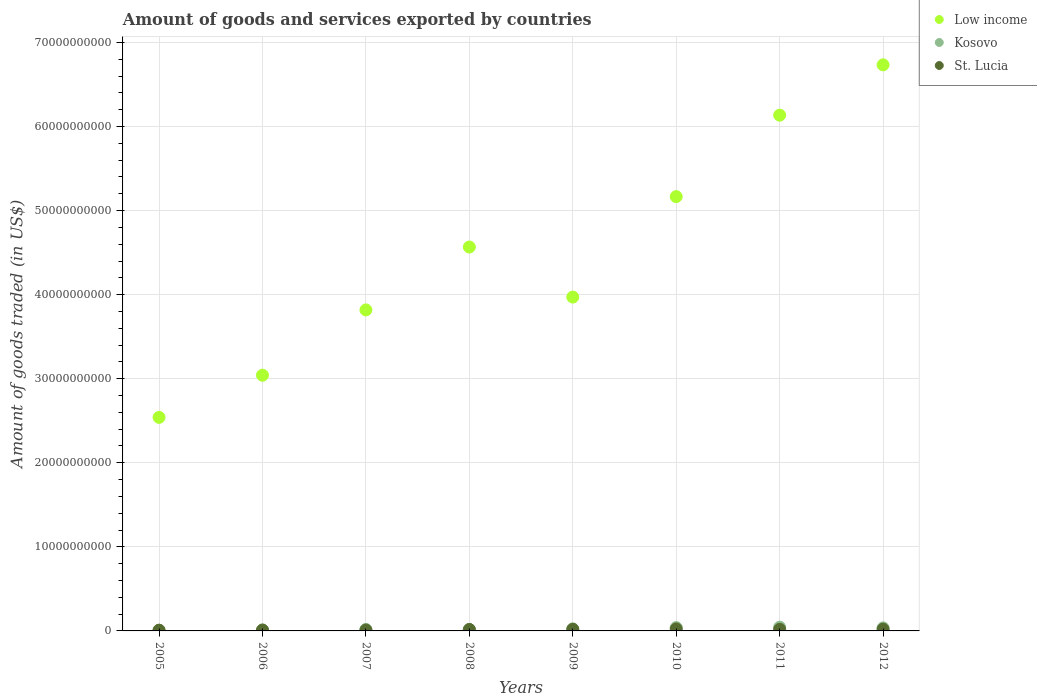What is the total amount of goods and services exported in Low income in 2007?
Offer a very short reply. 3.82e+1. Across all years, what is the maximum total amount of goods and services exported in Kosovo?
Give a very brief answer. 4.41e+08. Across all years, what is the minimum total amount of goods and services exported in Kosovo?
Give a very brief answer. 7.96e+07. In which year was the total amount of goods and services exported in Kosovo maximum?
Your answer should be compact. 2011. What is the total total amount of goods and services exported in Low income in the graph?
Make the answer very short. 3.60e+11. What is the difference between the total amount of goods and services exported in Kosovo in 2007 and that in 2010?
Give a very brief answer. -2.13e+08. What is the difference between the total amount of goods and services exported in Kosovo in 2005 and the total amount of goods and services exported in Low income in 2007?
Your answer should be compact. -3.81e+1. What is the average total amount of goods and services exported in St. Lucia per year?
Keep it short and to the point. 1.62e+08. In the year 2011, what is the difference between the total amount of goods and services exported in Kosovo and total amount of goods and services exported in St. Lucia?
Your answer should be compact. 2.49e+08. In how many years, is the total amount of goods and services exported in St. Lucia greater than 66000000000 US$?
Give a very brief answer. 0. What is the ratio of the total amount of goods and services exported in St. Lucia in 2005 to that in 2007?
Your answer should be very brief. 0.88. Is the total amount of goods and services exported in Kosovo in 2008 less than that in 2009?
Offer a very short reply. Yes. Is the difference between the total amount of goods and services exported in Kosovo in 2007 and 2010 greater than the difference between the total amount of goods and services exported in St. Lucia in 2007 and 2010?
Keep it short and to the point. No. What is the difference between the highest and the second highest total amount of goods and services exported in Kosovo?
Your answer should be very brief. 4.63e+07. What is the difference between the highest and the lowest total amount of goods and services exported in St. Lucia?
Give a very brief answer. 1.50e+08. Is the sum of the total amount of goods and services exported in Low income in 2007 and 2012 greater than the maximum total amount of goods and services exported in Kosovo across all years?
Make the answer very short. Yes. Is it the case that in every year, the sum of the total amount of goods and services exported in Kosovo and total amount of goods and services exported in Low income  is greater than the total amount of goods and services exported in St. Lucia?
Ensure brevity in your answer.  Yes. How many years are there in the graph?
Your answer should be very brief. 8. What is the difference between two consecutive major ticks on the Y-axis?
Ensure brevity in your answer.  1.00e+1. Are the values on the major ticks of Y-axis written in scientific E-notation?
Your answer should be compact. No. Does the graph contain grids?
Ensure brevity in your answer.  Yes. How are the legend labels stacked?
Make the answer very short. Vertical. What is the title of the graph?
Ensure brevity in your answer.  Amount of goods and services exported by countries. Does "Swaziland" appear as one of the legend labels in the graph?
Give a very brief answer. No. What is the label or title of the X-axis?
Your answer should be compact. Years. What is the label or title of the Y-axis?
Make the answer very short. Amount of goods traded (in US$). What is the Amount of goods traded (in US$) of Low income in 2005?
Offer a very short reply. 2.54e+1. What is the Amount of goods traded (in US$) of Kosovo in 2005?
Your answer should be very brief. 7.96e+07. What is the Amount of goods traded (in US$) in St. Lucia in 2005?
Provide a short and direct response. 8.88e+07. What is the Amount of goods traded (in US$) in Low income in 2006?
Ensure brevity in your answer.  3.04e+1. What is the Amount of goods traded (in US$) of Kosovo in 2006?
Offer a terse response. 1.24e+08. What is the Amount of goods traded (in US$) of St. Lucia in 2006?
Offer a very short reply. 9.66e+07. What is the Amount of goods traded (in US$) in Low income in 2007?
Give a very brief answer. 3.82e+1. What is the Amount of goods traded (in US$) in Kosovo in 2007?
Your answer should be very brief. 1.82e+08. What is the Amount of goods traded (in US$) of St. Lucia in 2007?
Keep it short and to the point. 1.01e+08. What is the Amount of goods traded (in US$) in Low income in 2008?
Your answer should be compact. 4.57e+1. What is the Amount of goods traded (in US$) of Kosovo in 2008?
Make the answer very short. 1.76e+08. What is the Amount of goods traded (in US$) in St. Lucia in 2008?
Offer a very short reply. 1.72e+08. What is the Amount of goods traded (in US$) in Low income in 2009?
Ensure brevity in your answer.  3.97e+1. What is the Amount of goods traded (in US$) in Kosovo in 2009?
Provide a succinct answer. 2.43e+08. What is the Amount of goods traded (in US$) of St. Lucia in 2009?
Your response must be concise. 1.91e+08. What is the Amount of goods traded (in US$) in Low income in 2010?
Make the answer very short. 5.17e+1. What is the Amount of goods traded (in US$) in Kosovo in 2010?
Give a very brief answer. 3.95e+08. What is the Amount of goods traded (in US$) of St. Lucia in 2010?
Your answer should be compact. 2.39e+08. What is the Amount of goods traded (in US$) in Low income in 2011?
Ensure brevity in your answer.  6.13e+1. What is the Amount of goods traded (in US$) in Kosovo in 2011?
Offer a terse response. 4.41e+08. What is the Amount of goods traded (in US$) of St. Lucia in 2011?
Give a very brief answer. 1.92e+08. What is the Amount of goods traded (in US$) of Low income in 2012?
Offer a terse response. 6.73e+1. What is the Amount of goods traded (in US$) in Kosovo in 2012?
Ensure brevity in your answer.  3.62e+08. What is the Amount of goods traded (in US$) in St. Lucia in 2012?
Offer a very short reply. 2.12e+08. Across all years, what is the maximum Amount of goods traded (in US$) in Low income?
Your answer should be very brief. 6.73e+1. Across all years, what is the maximum Amount of goods traded (in US$) in Kosovo?
Your answer should be compact. 4.41e+08. Across all years, what is the maximum Amount of goods traded (in US$) of St. Lucia?
Your answer should be very brief. 2.39e+08. Across all years, what is the minimum Amount of goods traded (in US$) of Low income?
Provide a succinct answer. 2.54e+1. Across all years, what is the minimum Amount of goods traded (in US$) of Kosovo?
Your answer should be very brief. 7.96e+07. Across all years, what is the minimum Amount of goods traded (in US$) of St. Lucia?
Your response must be concise. 8.88e+07. What is the total Amount of goods traded (in US$) in Low income in the graph?
Your answer should be compact. 3.60e+11. What is the total Amount of goods traded (in US$) of Kosovo in the graph?
Ensure brevity in your answer.  2.00e+09. What is the total Amount of goods traded (in US$) of St. Lucia in the graph?
Your answer should be compact. 1.29e+09. What is the difference between the Amount of goods traded (in US$) of Low income in 2005 and that in 2006?
Your answer should be very brief. -5.01e+09. What is the difference between the Amount of goods traded (in US$) of Kosovo in 2005 and that in 2006?
Provide a succinct answer. -4.40e+07. What is the difference between the Amount of goods traded (in US$) of St. Lucia in 2005 and that in 2006?
Your answer should be compact. -7.88e+06. What is the difference between the Amount of goods traded (in US$) of Low income in 2005 and that in 2007?
Provide a succinct answer. -1.28e+1. What is the difference between the Amount of goods traded (in US$) in Kosovo in 2005 and that in 2007?
Provide a succinct answer. -1.02e+08. What is the difference between the Amount of goods traded (in US$) in St. Lucia in 2005 and that in 2007?
Make the answer very short. -1.24e+07. What is the difference between the Amount of goods traded (in US$) in Low income in 2005 and that in 2008?
Provide a succinct answer. -2.03e+1. What is the difference between the Amount of goods traded (in US$) of Kosovo in 2005 and that in 2008?
Give a very brief answer. -9.60e+07. What is the difference between the Amount of goods traded (in US$) of St. Lucia in 2005 and that in 2008?
Keep it short and to the point. -8.37e+07. What is the difference between the Amount of goods traded (in US$) of Low income in 2005 and that in 2009?
Your response must be concise. -1.43e+1. What is the difference between the Amount of goods traded (in US$) in Kosovo in 2005 and that in 2009?
Offer a very short reply. -1.63e+08. What is the difference between the Amount of goods traded (in US$) in St. Lucia in 2005 and that in 2009?
Give a very brief answer. -1.03e+08. What is the difference between the Amount of goods traded (in US$) in Low income in 2005 and that in 2010?
Provide a short and direct response. -2.63e+1. What is the difference between the Amount of goods traded (in US$) in Kosovo in 2005 and that in 2010?
Offer a terse response. -3.15e+08. What is the difference between the Amount of goods traded (in US$) in St. Lucia in 2005 and that in 2010?
Make the answer very short. -1.50e+08. What is the difference between the Amount of goods traded (in US$) of Low income in 2005 and that in 2011?
Offer a very short reply. -3.59e+1. What is the difference between the Amount of goods traded (in US$) in Kosovo in 2005 and that in 2011?
Your answer should be compact. -3.62e+08. What is the difference between the Amount of goods traded (in US$) in St. Lucia in 2005 and that in 2011?
Give a very brief answer. -1.04e+08. What is the difference between the Amount of goods traded (in US$) of Low income in 2005 and that in 2012?
Provide a short and direct response. -4.19e+1. What is the difference between the Amount of goods traded (in US$) of Kosovo in 2005 and that in 2012?
Give a very brief answer. -2.82e+08. What is the difference between the Amount of goods traded (in US$) in St. Lucia in 2005 and that in 2012?
Ensure brevity in your answer.  -1.24e+08. What is the difference between the Amount of goods traded (in US$) in Low income in 2006 and that in 2007?
Offer a very short reply. -7.77e+09. What is the difference between the Amount of goods traded (in US$) in Kosovo in 2006 and that in 2007?
Provide a short and direct response. -5.80e+07. What is the difference between the Amount of goods traded (in US$) in St. Lucia in 2006 and that in 2007?
Your response must be concise. -4.57e+06. What is the difference between the Amount of goods traded (in US$) of Low income in 2006 and that in 2008?
Offer a terse response. -1.52e+1. What is the difference between the Amount of goods traded (in US$) in Kosovo in 2006 and that in 2008?
Make the answer very short. -5.21e+07. What is the difference between the Amount of goods traded (in US$) of St. Lucia in 2006 and that in 2008?
Offer a terse response. -7.58e+07. What is the difference between the Amount of goods traded (in US$) in Low income in 2006 and that in 2009?
Ensure brevity in your answer.  -9.30e+09. What is the difference between the Amount of goods traded (in US$) in Kosovo in 2006 and that in 2009?
Offer a very short reply. -1.19e+08. What is the difference between the Amount of goods traded (in US$) in St. Lucia in 2006 and that in 2009?
Offer a very short reply. -9.47e+07. What is the difference between the Amount of goods traded (in US$) in Low income in 2006 and that in 2010?
Provide a short and direct response. -2.12e+1. What is the difference between the Amount of goods traded (in US$) of Kosovo in 2006 and that in 2010?
Your answer should be compact. -2.71e+08. What is the difference between the Amount of goods traded (in US$) of St. Lucia in 2006 and that in 2010?
Your answer should be compact. -1.42e+08. What is the difference between the Amount of goods traded (in US$) of Low income in 2006 and that in 2011?
Keep it short and to the point. -3.09e+1. What is the difference between the Amount of goods traded (in US$) in Kosovo in 2006 and that in 2011?
Provide a succinct answer. -3.18e+08. What is the difference between the Amount of goods traded (in US$) in St. Lucia in 2006 and that in 2011?
Keep it short and to the point. -9.56e+07. What is the difference between the Amount of goods traded (in US$) in Low income in 2006 and that in 2012?
Provide a succinct answer. -3.69e+1. What is the difference between the Amount of goods traded (in US$) of Kosovo in 2006 and that in 2012?
Ensure brevity in your answer.  -2.38e+08. What is the difference between the Amount of goods traded (in US$) in St. Lucia in 2006 and that in 2012?
Make the answer very short. -1.16e+08. What is the difference between the Amount of goods traded (in US$) in Low income in 2007 and that in 2008?
Give a very brief answer. -7.48e+09. What is the difference between the Amount of goods traded (in US$) in Kosovo in 2007 and that in 2008?
Your answer should be very brief. 5.88e+06. What is the difference between the Amount of goods traded (in US$) of St. Lucia in 2007 and that in 2008?
Provide a short and direct response. -7.13e+07. What is the difference between the Amount of goods traded (in US$) of Low income in 2007 and that in 2009?
Make the answer very short. -1.53e+09. What is the difference between the Amount of goods traded (in US$) in Kosovo in 2007 and that in 2009?
Offer a very short reply. -6.15e+07. What is the difference between the Amount of goods traded (in US$) in St. Lucia in 2007 and that in 2009?
Offer a terse response. -9.01e+07. What is the difference between the Amount of goods traded (in US$) of Low income in 2007 and that in 2010?
Your answer should be compact. -1.35e+1. What is the difference between the Amount of goods traded (in US$) in Kosovo in 2007 and that in 2010?
Offer a terse response. -2.13e+08. What is the difference between the Amount of goods traded (in US$) in St. Lucia in 2007 and that in 2010?
Make the answer very short. -1.38e+08. What is the difference between the Amount of goods traded (in US$) of Low income in 2007 and that in 2011?
Make the answer very short. -2.32e+1. What is the difference between the Amount of goods traded (in US$) in Kosovo in 2007 and that in 2011?
Your response must be concise. -2.60e+08. What is the difference between the Amount of goods traded (in US$) of St. Lucia in 2007 and that in 2011?
Provide a succinct answer. -9.11e+07. What is the difference between the Amount of goods traded (in US$) in Low income in 2007 and that in 2012?
Your response must be concise. -2.92e+1. What is the difference between the Amount of goods traded (in US$) of Kosovo in 2007 and that in 2012?
Your answer should be compact. -1.81e+08. What is the difference between the Amount of goods traded (in US$) in St. Lucia in 2007 and that in 2012?
Your answer should be compact. -1.11e+08. What is the difference between the Amount of goods traded (in US$) of Low income in 2008 and that in 2009?
Keep it short and to the point. 5.95e+09. What is the difference between the Amount of goods traded (in US$) of Kosovo in 2008 and that in 2009?
Ensure brevity in your answer.  -6.73e+07. What is the difference between the Amount of goods traded (in US$) in St. Lucia in 2008 and that in 2009?
Provide a succinct answer. -1.88e+07. What is the difference between the Amount of goods traded (in US$) of Low income in 2008 and that in 2010?
Your answer should be very brief. -6.00e+09. What is the difference between the Amount of goods traded (in US$) in Kosovo in 2008 and that in 2010?
Provide a succinct answer. -2.19e+08. What is the difference between the Amount of goods traded (in US$) of St. Lucia in 2008 and that in 2010?
Make the answer very short. -6.64e+07. What is the difference between the Amount of goods traded (in US$) in Low income in 2008 and that in 2011?
Provide a short and direct response. -1.57e+1. What is the difference between the Amount of goods traded (in US$) of Kosovo in 2008 and that in 2011?
Provide a succinct answer. -2.66e+08. What is the difference between the Amount of goods traded (in US$) in St. Lucia in 2008 and that in 2011?
Your answer should be very brief. -1.98e+07. What is the difference between the Amount of goods traded (in US$) in Low income in 2008 and that in 2012?
Give a very brief answer. -2.17e+1. What is the difference between the Amount of goods traded (in US$) in Kosovo in 2008 and that in 2012?
Your answer should be compact. -1.86e+08. What is the difference between the Amount of goods traded (in US$) of St. Lucia in 2008 and that in 2012?
Make the answer very short. -4.00e+07. What is the difference between the Amount of goods traded (in US$) of Low income in 2009 and that in 2010?
Offer a very short reply. -1.19e+1. What is the difference between the Amount of goods traded (in US$) of Kosovo in 2009 and that in 2010?
Your answer should be compact. -1.52e+08. What is the difference between the Amount of goods traded (in US$) in St. Lucia in 2009 and that in 2010?
Make the answer very short. -4.76e+07. What is the difference between the Amount of goods traded (in US$) in Low income in 2009 and that in 2011?
Provide a short and direct response. -2.16e+1. What is the difference between the Amount of goods traded (in US$) in Kosovo in 2009 and that in 2011?
Your answer should be compact. -1.98e+08. What is the difference between the Amount of goods traded (in US$) of St. Lucia in 2009 and that in 2011?
Keep it short and to the point. -9.51e+05. What is the difference between the Amount of goods traded (in US$) in Low income in 2009 and that in 2012?
Keep it short and to the point. -2.76e+1. What is the difference between the Amount of goods traded (in US$) in Kosovo in 2009 and that in 2012?
Provide a succinct answer. -1.19e+08. What is the difference between the Amount of goods traded (in US$) of St. Lucia in 2009 and that in 2012?
Offer a terse response. -2.11e+07. What is the difference between the Amount of goods traded (in US$) in Low income in 2010 and that in 2011?
Give a very brief answer. -9.69e+09. What is the difference between the Amount of goods traded (in US$) in Kosovo in 2010 and that in 2011?
Provide a short and direct response. -4.63e+07. What is the difference between the Amount of goods traded (in US$) of St. Lucia in 2010 and that in 2011?
Offer a terse response. 4.66e+07. What is the difference between the Amount of goods traded (in US$) in Low income in 2010 and that in 2012?
Make the answer very short. -1.57e+1. What is the difference between the Amount of goods traded (in US$) in Kosovo in 2010 and that in 2012?
Keep it short and to the point. 3.28e+07. What is the difference between the Amount of goods traded (in US$) in St. Lucia in 2010 and that in 2012?
Give a very brief answer. 2.65e+07. What is the difference between the Amount of goods traded (in US$) of Low income in 2011 and that in 2012?
Offer a very short reply. -5.99e+09. What is the difference between the Amount of goods traded (in US$) in Kosovo in 2011 and that in 2012?
Provide a short and direct response. 7.92e+07. What is the difference between the Amount of goods traded (in US$) in St. Lucia in 2011 and that in 2012?
Provide a short and direct response. -2.02e+07. What is the difference between the Amount of goods traded (in US$) in Low income in 2005 and the Amount of goods traded (in US$) in Kosovo in 2006?
Provide a short and direct response. 2.53e+1. What is the difference between the Amount of goods traded (in US$) in Low income in 2005 and the Amount of goods traded (in US$) in St. Lucia in 2006?
Provide a short and direct response. 2.53e+1. What is the difference between the Amount of goods traded (in US$) of Kosovo in 2005 and the Amount of goods traded (in US$) of St. Lucia in 2006?
Offer a very short reply. -1.70e+07. What is the difference between the Amount of goods traded (in US$) in Low income in 2005 and the Amount of goods traded (in US$) in Kosovo in 2007?
Keep it short and to the point. 2.52e+1. What is the difference between the Amount of goods traded (in US$) of Low income in 2005 and the Amount of goods traded (in US$) of St. Lucia in 2007?
Keep it short and to the point. 2.53e+1. What is the difference between the Amount of goods traded (in US$) in Kosovo in 2005 and the Amount of goods traded (in US$) in St. Lucia in 2007?
Offer a very short reply. -2.16e+07. What is the difference between the Amount of goods traded (in US$) in Low income in 2005 and the Amount of goods traded (in US$) in Kosovo in 2008?
Your answer should be very brief. 2.52e+1. What is the difference between the Amount of goods traded (in US$) in Low income in 2005 and the Amount of goods traded (in US$) in St. Lucia in 2008?
Your answer should be very brief. 2.52e+1. What is the difference between the Amount of goods traded (in US$) of Kosovo in 2005 and the Amount of goods traded (in US$) of St. Lucia in 2008?
Offer a very short reply. -9.28e+07. What is the difference between the Amount of goods traded (in US$) of Low income in 2005 and the Amount of goods traded (in US$) of Kosovo in 2009?
Provide a succinct answer. 2.52e+1. What is the difference between the Amount of goods traded (in US$) in Low income in 2005 and the Amount of goods traded (in US$) in St. Lucia in 2009?
Ensure brevity in your answer.  2.52e+1. What is the difference between the Amount of goods traded (in US$) in Kosovo in 2005 and the Amount of goods traded (in US$) in St. Lucia in 2009?
Provide a short and direct response. -1.12e+08. What is the difference between the Amount of goods traded (in US$) in Low income in 2005 and the Amount of goods traded (in US$) in Kosovo in 2010?
Your response must be concise. 2.50e+1. What is the difference between the Amount of goods traded (in US$) in Low income in 2005 and the Amount of goods traded (in US$) in St. Lucia in 2010?
Your answer should be very brief. 2.52e+1. What is the difference between the Amount of goods traded (in US$) of Kosovo in 2005 and the Amount of goods traded (in US$) of St. Lucia in 2010?
Ensure brevity in your answer.  -1.59e+08. What is the difference between the Amount of goods traded (in US$) of Low income in 2005 and the Amount of goods traded (in US$) of Kosovo in 2011?
Ensure brevity in your answer.  2.50e+1. What is the difference between the Amount of goods traded (in US$) in Low income in 2005 and the Amount of goods traded (in US$) in St. Lucia in 2011?
Provide a succinct answer. 2.52e+1. What is the difference between the Amount of goods traded (in US$) in Kosovo in 2005 and the Amount of goods traded (in US$) in St. Lucia in 2011?
Keep it short and to the point. -1.13e+08. What is the difference between the Amount of goods traded (in US$) in Low income in 2005 and the Amount of goods traded (in US$) in Kosovo in 2012?
Provide a succinct answer. 2.50e+1. What is the difference between the Amount of goods traded (in US$) in Low income in 2005 and the Amount of goods traded (in US$) in St. Lucia in 2012?
Ensure brevity in your answer.  2.52e+1. What is the difference between the Amount of goods traded (in US$) in Kosovo in 2005 and the Amount of goods traded (in US$) in St. Lucia in 2012?
Offer a terse response. -1.33e+08. What is the difference between the Amount of goods traded (in US$) in Low income in 2006 and the Amount of goods traded (in US$) in Kosovo in 2007?
Make the answer very short. 3.02e+1. What is the difference between the Amount of goods traded (in US$) of Low income in 2006 and the Amount of goods traded (in US$) of St. Lucia in 2007?
Provide a short and direct response. 3.03e+1. What is the difference between the Amount of goods traded (in US$) in Kosovo in 2006 and the Amount of goods traded (in US$) in St. Lucia in 2007?
Provide a short and direct response. 2.24e+07. What is the difference between the Amount of goods traded (in US$) of Low income in 2006 and the Amount of goods traded (in US$) of Kosovo in 2008?
Provide a short and direct response. 3.02e+1. What is the difference between the Amount of goods traded (in US$) of Low income in 2006 and the Amount of goods traded (in US$) of St. Lucia in 2008?
Keep it short and to the point. 3.02e+1. What is the difference between the Amount of goods traded (in US$) of Kosovo in 2006 and the Amount of goods traded (in US$) of St. Lucia in 2008?
Give a very brief answer. -4.89e+07. What is the difference between the Amount of goods traded (in US$) in Low income in 2006 and the Amount of goods traded (in US$) in Kosovo in 2009?
Your answer should be compact. 3.02e+1. What is the difference between the Amount of goods traded (in US$) of Low income in 2006 and the Amount of goods traded (in US$) of St. Lucia in 2009?
Your answer should be compact. 3.02e+1. What is the difference between the Amount of goods traded (in US$) of Kosovo in 2006 and the Amount of goods traded (in US$) of St. Lucia in 2009?
Your answer should be compact. -6.77e+07. What is the difference between the Amount of goods traded (in US$) of Low income in 2006 and the Amount of goods traded (in US$) of Kosovo in 2010?
Your answer should be compact. 3.00e+1. What is the difference between the Amount of goods traded (in US$) in Low income in 2006 and the Amount of goods traded (in US$) in St. Lucia in 2010?
Make the answer very short. 3.02e+1. What is the difference between the Amount of goods traded (in US$) in Kosovo in 2006 and the Amount of goods traded (in US$) in St. Lucia in 2010?
Offer a very short reply. -1.15e+08. What is the difference between the Amount of goods traded (in US$) in Low income in 2006 and the Amount of goods traded (in US$) in Kosovo in 2011?
Make the answer very short. 3.00e+1. What is the difference between the Amount of goods traded (in US$) of Low income in 2006 and the Amount of goods traded (in US$) of St. Lucia in 2011?
Ensure brevity in your answer.  3.02e+1. What is the difference between the Amount of goods traded (in US$) of Kosovo in 2006 and the Amount of goods traded (in US$) of St. Lucia in 2011?
Offer a very short reply. -6.87e+07. What is the difference between the Amount of goods traded (in US$) in Low income in 2006 and the Amount of goods traded (in US$) in Kosovo in 2012?
Make the answer very short. 3.01e+1. What is the difference between the Amount of goods traded (in US$) of Low income in 2006 and the Amount of goods traded (in US$) of St. Lucia in 2012?
Make the answer very short. 3.02e+1. What is the difference between the Amount of goods traded (in US$) in Kosovo in 2006 and the Amount of goods traded (in US$) in St. Lucia in 2012?
Your answer should be compact. -8.88e+07. What is the difference between the Amount of goods traded (in US$) of Low income in 2007 and the Amount of goods traded (in US$) of Kosovo in 2008?
Keep it short and to the point. 3.80e+1. What is the difference between the Amount of goods traded (in US$) of Low income in 2007 and the Amount of goods traded (in US$) of St. Lucia in 2008?
Give a very brief answer. 3.80e+1. What is the difference between the Amount of goods traded (in US$) in Kosovo in 2007 and the Amount of goods traded (in US$) in St. Lucia in 2008?
Make the answer very short. 9.08e+06. What is the difference between the Amount of goods traded (in US$) of Low income in 2007 and the Amount of goods traded (in US$) of Kosovo in 2009?
Make the answer very short. 3.79e+1. What is the difference between the Amount of goods traded (in US$) of Low income in 2007 and the Amount of goods traded (in US$) of St. Lucia in 2009?
Give a very brief answer. 3.80e+1. What is the difference between the Amount of goods traded (in US$) in Kosovo in 2007 and the Amount of goods traded (in US$) in St. Lucia in 2009?
Offer a terse response. -9.77e+06. What is the difference between the Amount of goods traded (in US$) of Low income in 2007 and the Amount of goods traded (in US$) of Kosovo in 2010?
Ensure brevity in your answer.  3.78e+1. What is the difference between the Amount of goods traded (in US$) in Low income in 2007 and the Amount of goods traded (in US$) in St. Lucia in 2010?
Provide a short and direct response. 3.79e+1. What is the difference between the Amount of goods traded (in US$) in Kosovo in 2007 and the Amount of goods traded (in US$) in St. Lucia in 2010?
Make the answer very short. -5.73e+07. What is the difference between the Amount of goods traded (in US$) of Low income in 2007 and the Amount of goods traded (in US$) of Kosovo in 2011?
Give a very brief answer. 3.77e+1. What is the difference between the Amount of goods traded (in US$) in Low income in 2007 and the Amount of goods traded (in US$) in St. Lucia in 2011?
Make the answer very short. 3.80e+1. What is the difference between the Amount of goods traded (in US$) of Kosovo in 2007 and the Amount of goods traded (in US$) of St. Lucia in 2011?
Your answer should be very brief. -1.07e+07. What is the difference between the Amount of goods traded (in US$) of Low income in 2007 and the Amount of goods traded (in US$) of Kosovo in 2012?
Your answer should be compact. 3.78e+1. What is the difference between the Amount of goods traded (in US$) in Low income in 2007 and the Amount of goods traded (in US$) in St. Lucia in 2012?
Provide a short and direct response. 3.80e+1. What is the difference between the Amount of goods traded (in US$) in Kosovo in 2007 and the Amount of goods traded (in US$) in St. Lucia in 2012?
Keep it short and to the point. -3.09e+07. What is the difference between the Amount of goods traded (in US$) of Low income in 2008 and the Amount of goods traded (in US$) of Kosovo in 2009?
Give a very brief answer. 4.54e+1. What is the difference between the Amount of goods traded (in US$) in Low income in 2008 and the Amount of goods traded (in US$) in St. Lucia in 2009?
Your answer should be very brief. 4.55e+1. What is the difference between the Amount of goods traded (in US$) of Kosovo in 2008 and the Amount of goods traded (in US$) of St. Lucia in 2009?
Keep it short and to the point. -1.56e+07. What is the difference between the Amount of goods traded (in US$) of Low income in 2008 and the Amount of goods traded (in US$) of Kosovo in 2010?
Give a very brief answer. 4.53e+1. What is the difference between the Amount of goods traded (in US$) of Low income in 2008 and the Amount of goods traded (in US$) of St. Lucia in 2010?
Offer a terse response. 4.54e+1. What is the difference between the Amount of goods traded (in US$) in Kosovo in 2008 and the Amount of goods traded (in US$) in St. Lucia in 2010?
Provide a succinct answer. -6.32e+07. What is the difference between the Amount of goods traded (in US$) in Low income in 2008 and the Amount of goods traded (in US$) in Kosovo in 2011?
Keep it short and to the point. 4.52e+1. What is the difference between the Amount of goods traded (in US$) in Low income in 2008 and the Amount of goods traded (in US$) in St. Lucia in 2011?
Ensure brevity in your answer.  4.55e+1. What is the difference between the Amount of goods traded (in US$) in Kosovo in 2008 and the Amount of goods traded (in US$) in St. Lucia in 2011?
Give a very brief answer. -1.66e+07. What is the difference between the Amount of goods traded (in US$) of Low income in 2008 and the Amount of goods traded (in US$) of Kosovo in 2012?
Provide a short and direct response. 4.53e+1. What is the difference between the Amount of goods traded (in US$) of Low income in 2008 and the Amount of goods traded (in US$) of St. Lucia in 2012?
Offer a very short reply. 4.55e+1. What is the difference between the Amount of goods traded (in US$) of Kosovo in 2008 and the Amount of goods traded (in US$) of St. Lucia in 2012?
Offer a very short reply. -3.68e+07. What is the difference between the Amount of goods traded (in US$) in Low income in 2009 and the Amount of goods traded (in US$) in Kosovo in 2010?
Offer a terse response. 3.93e+1. What is the difference between the Amount of goods traded (in US$) in Low income in 2009 and the Amount of goods traded (in US$) in St. Lucia in 2010?
Offer a terse response. 3.95e+1. What is the difference between the Amount of goods traded (in US$) in Kosovo in 2009 and the Amount of goods traded (in US$) in St. Lucia in 2010?
Your response must be concise. 4.12e+06. What is the difference between the Amount of goods traded (in US$) of Low income in 2009 and the Amount of goods traded (in US$) of Kosovo in 2011?
Your answer should be compact. 3.93e+1. What is the difference between the Amount of goods traded (in US$) of Low income in 2009 and the Amount of goods traded (in US$) of St. Lucia in 2011?
Keep it short and to the point. 3.95e+1. What is the difference between the Amount of goods traded (in US$) of Kosovo in 2009 and the Amount of goods traded (in US$) of St. Lucia in 2011?
Keep it short and to the point. 5.07e+07. What is the difference between the Amount of goods traded (in US$) in Low income in 2009 and the Amount of goods traded (in US$) in Kosovo in 2012?
Provide a short and direct response. 3.93e+1. What is the difference between the Amount of goods traded (in US$) of Low income in 2009 and the Amount of goods traded (in US$) of St. Lucia in 2012?
Your answer should be very brief. 3.95e+1. What is the difference between the Amount of goods traded (in US$) in Kosovo in 2009 and the Amount of goods traded (in US$) in St. Lucia in 2012?
Make the answer very short. 3.06e+07. What is the difference between the Amount of goods traded (in US$) of Low income in 2010 and the Amount of goods traded (in US$) of Kosovo in 2011?
Offer a very short reply. 5.12e+1. What is the difference between the Amount of goods traded (in US$) of Low income in 2010 and the Amount of goods traded (in US$) of St. Lucia in 2011?
Make the answer very short. 5.15e+1. What is the difference between the Amount of goods traded (in US$) in Kosovo in 2010 and the Amount of goods traded (in US$) in St. Lucia in 2011?
Your answer should be very brief. 2.03e+08. What is the difference between the Amount of goods traded (in US$) in Low income in 2010 and the Amount of goods traded (in US$) in Kosovo in 2012?
Keep it short and to the point. 5.13e+1. What is the difference between the Amount of goods traded (in US$) of Low income in 2010 and the Amount of goods traded (in US$) of St. Lucia in 2012?
Your answer should be compact. 5.14e+1. What is the difference between the Amount of goods traded (in US$) of Kosovo in 2010 and the Amount of goods traded (in US$) of St. Lucia in 2012?
Provide a short and direct response. 1.82e+08. What is the difference between the Amount of goods traded (in US$) of Low income in 2011 and the Amount of goods traded (in US$) of Kosovo in 2012?
Your response must be concise. 6.10e+1. What is the difference between the Amount of goods traded (in US$) of Low income in 2011 and the Amount of goods traded (in US$) of St. Lucia in 2012?
Keep it short and to the point. 6.11e+1. What is the difference between the Amount of goods traded (in US$) in Kosovo in 2011 and the Amount of goods traded (in US$) in St. Lucia in 2012?
Provide a succinct answer. 2.29e+08. What is the average Amount of goods traded (in US$) of Low income per year?
Your response must be concise. 4.50e+1. What is the average Amount of goods traded (in US$) in Kosovo per year?
Keep it short and to the point. 2.50e+08. What is the average Amount of goods traded (in US$) of St. Lucia per year?
Provide a short and direct response. 1.62e+08. In the year 2005, what is the difference between the Amount of goods traded (in US$) of Low income and Amount of goods traded (in US$) of Kosovo?
Provide a succinct answer. 2.53e+1. In the year 2005, what is the difference between the Amount of goods traded (in US$) of Low income and Amount of goods traded (in US$) of St. Lucia?
Keep it short and to the point. 2.53e+1. In the year 2005, what is the difference between the Amount of goods traded (in US$) in Kosovo and Amount of goods traded (in US$) in St. Lucia?
Give a very brief answer. -9.14e+06. In the year 2006, what is the difference between the Amount of goods traded (in US$) of Low income and Amount of goods traded (in US$) of Kosovo?
Make the answer very short. 3.03e+1. In the year 2006, what is the difference between the Amount of goods traded (in US$) of Low income and Amount of goods traded (in US$) of St. Lucia?
Make the answer very short. 3.03e+1. In the year 2006, what is the difference between the Amount of goods traded (in US$) of Kosovo and Amount of goods traded (in US$) of St. Lucia?
Your answer should be very brief. 2.70e+07. In the year 2007, what is the difference between the Amount of goods traded (in US$) in Low income and Amount of goods traded (in US$) in Kosovo?
Keep it short and to the point. 3.80e+1. In the year 2007, what is the difference between the Amount of goods traded (in US$) in Low income and Amount of goods traded (in US$) in St. Lucia?
Your answer should be compact. 3.81e+1. In the year 2007, what is the difference between the Amount of goods traded (in US$) in Kosovo and Amount of goods traded (in US$) in St. Lucia?
Offer a very short reply. 8.03e+07. In the year 2008, what is the difference between the Amount of goods traded (in US$) of Low income and Amount of goods traded (in US$) of Kosovo?
Ensure brevity in your answer.  4.55e+1. In the year 2008, what is the difference between the Amount of goods traded (in US$) of Low income and Amount of goods traded (in US$) of St. Lucia?
Give a very brief answer. 4.55e+1. In the year 2008, what is the difference between the Amount of goods traded (in US$) in Kosovo and Amount of goods traded (in US$) in St. Lucia?
Ensure brevity in your answer.  3.20e+06. In the year 2009, what is the difference between the Amount of goods traded (in US$) of Low income and Amount of goods traded (in US$) of Kosovo?
Offer a terse response. 3.95e+1. In the year 2009, what is the difference between the Amount of goods traded (in US$) of Low income and Amount of goods traded (in US$) of St. Lucia?
Give a very brief answer. 3.95e+1. In the year 2009, what is the difference between the Amount of goods traded (in US$) of Kosovo and Amount of goods traded (in US$) of St. Lucia?
Your answer should be compact. 5.17e+07. In the year 2010, what is the difference between the Amount of goods traded (in US$) of Low income and Amount of goods traded (in US$) of Kosovo?
Ensure brevity in your answer.  5.13e+1. In the year 2010, what is the difference between the Amount of goods traded (in US$) of Low income and Amount of goods traded (in US$) of St. Lucia?
Offer a very short reply. 5.14e+1. In the year 2010, what is the difference between the Amount of goods traded (in US$) in Kosovo and Amount of goods traded (in US$) in St. Lucia?
Provide a short and direct response. 1.56e+08. In the year 2011, what is the difference between the Amount of goods traded (in US$) in Low income and Amount of goods traded (in US$) in Kosovo?
Make the answer very short. 6.09e+1. In the year 2011, what is the difference between the Amount of goods traded (in US$) in Low income and Amount of goods traded (in US$) in St. Lucia?
Give a very brief answer. 6.12e+1. In the year 2011, what is the difference between the Amount of goods traded (in US$) of Kosovo and Amount of goods traded (in US$) of St. Lucia?
Your answer should be very brief. 2.49e+08. In the year 2012, what is the difference between the Amount of goods traded (in US$) of Low income and Amount of goods traded (in US$) of Kosovo?
Give a very brief answer. 6.70e+1. In the year 2012, what is the difference between the Amount of goods traded (in US$) of Low income and Amount of goods traded (in US$) of St. Lucia?
Ensure brevity in your answer.  6.71e+1. In the year 2012, what is the difference between the Amount of goods traded (in US$) of Kosovo and Amount of goods traded (in US$) of St. Lucia?
Make the answer very short. 1.50e+08. What is the ratio of the Amount of goods traded (in US$) in Low income in 2005 to that in 2006?
Offer a terse response. 0.84. What is the ratio of the Amount of goods traded (in US$) in Kosovo in 2005 to that in 2006?
Ensure brevity in your answer.  0.64. What is the ratio of the Amount of goods traded (in US$) in St. Lucia in 2005 to that in 2006?
Your response must be concise. 0.92. What is the ratio of the Amount of goods traded (in US$) in Low income in 2005 to that in 2007?
Provide a short and direct response. 0.67. What is the ratio of the Amount of goods traded (in US$) of Kosovo in 2005 to that in 2007?
Provide a succinct answer. 0.44. What is the ratio of the Amount of goods traded (in US$) of St. Lucia in 2005 to that in 2007?
Your answer should be very brief. 0.88. What is the ratio of the Amount of goods traded (in US$) in Low income in 2005 to that in 2008?
Give a very brief answer. 0.56. What is the ratio of the Amount of goods traded (in US$) of Kosovo in 2005 to that in 2008?
Your answer should be very brief. 0.45. What is the ratio of the Amount of goods traded (in US$) in St. Lucia in 2005 to that in 2008?
Make the answer very short. 0.51. What is the ratio of the Amount of goods traded (in US$) in Low income in 2005 to that in 2009?
Ensure brevity in your answer.  0.64. What is the ratio of the Amount of goods traded (in US$) in Kosovo in 2005 to that in 2009?
Provide a succinct answer. 0.33. What is the ratio of the Amount of goods traded (in US$) in St. Lucia in 2005 to that in 2009?
Offer a terse response. 0.46. What is the ratio of the Amount of goods traded (in US$) in Low income in 2005 to that in 2010?
Make the answer very short. 0.49. What is the ratio of the Amount of goods traded (in US$) of Kosovo in 2005 to that in 2010?
Ensure brevity in your answer.  0.2. What is the ratio of the Amount of goods traded (in US$) in St. Lucia in 2005 to that in 2010?
Provide a succinct answer. 0.37. What is the ratio of the Amount of goods traded (in US$) of Low income in 2005 to that in 2011?
Provide a succinct answer. 0.41. What is the ratio of the Amount of goods traded (in US$) in Kosovo in 2005 to that in 2011?
Make the answer very short. 0.18. What is the ratio of the Amount of goods traded (in US$) of St. Lucia in 2005 to that in 2011?
Make the answer very short. 0.46. What is the ratio of the Amount of goods traded (in US$) of Low income in 2005 to that in 2012?
Make the answer very short. 0.38. What is the ratio of the Amount of goods traded (in US$) of Kosovo in 2005 to that in 2012?
Provide a short and direct response. 0.22. What is the ratio of the Amount of goods traded (in US$) in St. Lucia in 2005 to that in 2012?
Give a very brief answer. 0.42. What is the ratio of the Amount of goods traded (in US$) in Low income in 2006 to that in 2007?
Make the answer very short. 0.8. What is the ratio of the Amount of goods traded (in US$) of Kosovo in 2006 to that in 2007?
Your answer should be compact. 0.68. What is the ratio of the Amount of goods traded (in US$) in St. Lucia in 2006 to that in 2007?
Give a very brief answer. 0.95. What is the ratio of the Amount of goods traded (in US$) of Low income in 2006 to that in 2008?
Give a very brief answer. 0.67. What is the ratio of the Amount of goods traded (in US$) of Kosovo in 2006 to that in 2008?
Provide a short and direct response. 0.7. What is the ratio of the Amount of goods traded (in US$) in St. Lucia in 2006 to that in 2008?
Provide a succinct answer. 0.56. What is the ratio of the Amount of goods traded (in US$) of Low income in 2006 to that in 2009?
Your answer should be compact. 0.77. What is the ratio of the Amount of goods traded (in US$) of Kosovo in 2006 to that in 2009?
Provide a succinct answer. 0.51. What is the ratio of the Amount of goods traded (in US$) of St. Lucia in 2006 to that in 2009?
Your response must be concise. 0.51. What is the ratio of the Amount of goods traded (in US$) of Low income in 2006 to that in 2010?
Make the answer very short. 0.59. What is the ratio of the Amount of goods traded (in US$) in Kosovo in 2006 to that in 2010?
Ensure brevity in your answer.  0.31. What is the ratio of the Amount of goods traded (in US$) of St. Lucia in 2006 to that in 2010?
Your answer should be compact. 0.4. What is the ratio of the Amount of goods traded (in US$) in Low income in 2006 to that in 2011?
Ensure brevity in your answer.  0.5. What is the ratio of the Amount of goods traded (in US$) in Kosovo in 2006 to that in 2011?
Give a very brief answer. 0.28. What is the ratio of the Amount of goods traded (in US$) of St. Lucia in 2006 to that in 2011?
Offer a very short reply. 0.5. What is the ratio of the Amount of goods traded (in US$) of Low income in 2006 to that in 2012?
Provide a succinct answer. 0.45. What is the ratio of the Amount of goods traded (in US$) of Kosovo in 2006 to that in 2012?
Your answer should be compact. 0.34. What is the ratio of the Amount of goods traded (in US$) of St. Lucia in 2006 to that in 2012?
Your response must be concise. 0.45. What is the ratio of the Amount of goods traded (in US$) of Low income in 2007 to that in 2008?
Make the answer very short. 0.84. What is the ratio of the Amount of goods traded (in US$) in Kosovo in 2007 to that in 2008?
Make the answer very short. 1.03. What is the ratio of the Amount of goods traded (in US$) of St. Lucia in 2007 to that in 2008?
Provide a succinct answer. 0.59. What is the ratio of the Amount of goods traded (in US$) of Low income in 2007 to that in 2009?
Give a very brief answer. 0.96. What is the ratio of the Amount of goods traded (in US$) of Kosovo in 2007 to that in 2009?
Provide a short and direct response. 0.75. What is the ratio of the Amount of goods traded (in US$) of St. Lucia in 2007 to that in 2009?
Your answer should be compact. 0.53. What is the ratio of the Amount of goods traded (in US$) in Low income in 2007 to that in 2010?
Give a very brief answer. 0.74. What is the ratio of the Amount of goods traded (in US$) of Kosovo in 2007 to that in 2010?
Your answer should be compact. 0.46. What is the ratio of the Amount of goods traded (in US$) in St. Lucia in 2007 to that in 2010?
Offer a terse response. 0.42. What is the ratio of the Amount of goods traded (in US$) of Low income in 2007 to that in 2011?
Your answer should be very brief. 0.62. What is the ratio of the Amount of goods traded (in US$) in Kosovo in 2007 to that in 2011?
Your answer should be compact. 0.41. What is the ratio of the Amount of goods traded (in US$) of St. Lucia in 2007 to that in 2011?
Your response must be concise. 0.53. What is the ratio of the Amount of goods traded (in US$) in Low income in 2007 to that in 2012?
Keep it short and to the point. 0.57. What is the ratio of the Amount of goods traded (in US$) of Kosovo in 2007 to that in 2012?
Keep it short and to the point. 0.5. What is the ratio of the Amount of goods traded (in US$) of St. Lucia in 2007 to that in 2012?
Your answer should be very brief. 0.48. What is the ratio of the Amount of goods traded (in US$) of Low income in 2008 to that in 2009?
Provide a short and direct response. 1.15. What is the ratio of the Amount of goods traded (in US$) of Kosovo in 2008 to that in 2009?
Ensure brevity in your answer.  0.72. What is the ratio of the Amount of goods traded (in US$) of St. Lucia in 2008 to that in 2009?
Provide a succinct answer. 0.9. What is the ratio of the Amount of goods traded (in US$) of Low income in 2008 to that in 2010?
Keep it short and to the point. 0.88. What is the ratio of the Amount of goods traded (in US$) in Kosovo in 2008 to that in 2010?
Offer a terse response. 0.44. What is the ratio of the Amount of goods traded (in US$) of St. Lucia in 2008 to that in 2010?
Make the answer very short. 0.72. What is the ratio of the Amount of goods traded (in US$) in Low income in 2008 to that in 2011?
Ensure brevity in your answer.  0.74. What is the ratio of the Amount of goods traded (in US$) of Kosovo in 2008 to that in 2011?
Your response must be concise. 0.4. What is the ratio of the Amount of goods traded (in US$) in St. Lucia in 2008 to that in 2011?
Your response must be concise. 0.9. What is the ratio of the Amount of goods traded (in US$) of Low income in 2008 to that in 2012?
Ensure brevity in your answer.  0.68. What is the ratio of the Amount of goods traded (in US$) of Kosovo in 2008 to that in 2012?
Your answer should be very brief. 0.49. What is the ratio of the Amount of goods traded (in US$) in St. Lucia in 2008 to that in 2012?
Your response must be concise. 0.81. What is the ratio of the Amount of goods traded (in US$) of Low income in 2009 to that in 2010?
Your answer should be very brief. 0.77. What is the ratio of the Amount of goods traded (in US$) of Kosovo in 2009 to that in 2010?
Your answer should be very brief. 0.62. What is the ratio of the Amount of goods traded (in US$) in St. Lucia in 2009 to that in 2010?
Provide a short and direct response. 0.8. What is the ratio of the Amount of goods traded (in US$) in Low income in 2009 to that in 2011?
Your answer should be compact. 0.65. What is the ratio of the Amount of goods traded (in US$) in Kosovo in 2009 to that in 2011?
Provide a succinct answer. 0.55. What is the ratio of the Amount of goods traded (in US$) in Low income in 2009 to that in 2012?
Ensure brevity in your answer.  0.59. What is the ratio of the Amount of goods traded (in US$) of Kosovo in 2009 to that in 2012?
Ensure brevity in your answer.  0.67. What is the ratio of the Amount of goods traded (in US$) of St. Lucia in 2009 to that in 2012?
Ensure brevity in your answer.  0.9. What is the ratio of the Amount of goods traded (in US$) of Low income in 2010 to that in 2011?
Keep it short and to the point. 0.84. What is the ratio of the Amount of goods traded (in US$) of Kosovo in 2010 to that in 2011?
Your response must be concise. 0.9. What is the ratio of the Amount of goods traded (in US$) in St. Lucia in 2010 to that in 2011?
Offer a very short reply. 1.24. What is the ratio of the Amount of goods traded (in US$) of Low income in 2010 to that in 2012?
Keep it short and to the point. 0.77. What is the ratio of the Amount of goods traded (in US$) in Kosovo in 2010 to that in 2012?
Offer a terse response. 1.09. What is the ratio of the Amount of goods traded (in US$) in St. Lucia in 2010 to that in 2012?
Provide a succinct answer. 1.12. What is the ratio of the Amount of goods traded (in US$) in Low income in 2011 to that in 2012?
Provide a succinct answer. 0.91. What is the ratio of the Amount of goods traded (in US$) of Kosovo in 2011 to that in 2012?
Ensure brevity in your answer.  1.22. What is the ratio of the Amount of goods traded (in US$) of St. Lucia in 2011 to that in 2012?
Keep it short and to the point. 0.91. What is the difference between the highest and the second highest Amount of goods traded (in US$) in Low income?
Provide a succinct answer. 5.99e+09. What is the difference between the highest and the second highest Amount of goods traded (in US$) of Kosovo?
Offer a very short reply. 4.63e+07. What is the difference between the highest and the second highest Amount of goods traded (in US$) in St. Lucia?
Provide a short and direct response. 2.65e+07. What is the difference between the highest and the lowest Amount of goods traded (in US$) of Low income?
Your response must be concise. 4.19e+1. What is the difference between the highest and the lowest Amount of goods traded (in US$) of Kosovo?
Your answer should be compact. 3.62e+08. What is the difference between the highest and the lowest Amount of goods traded (in US$) of St. Lucia?
Offer a very short reply. 1.50e+08. 